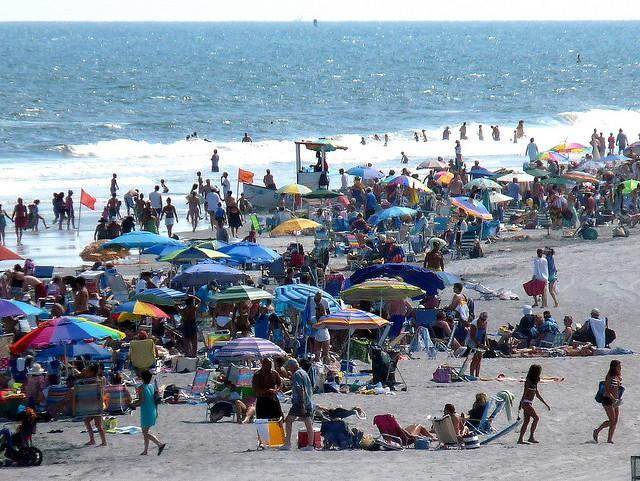What is the person in the elevated stand watching? swimmers 